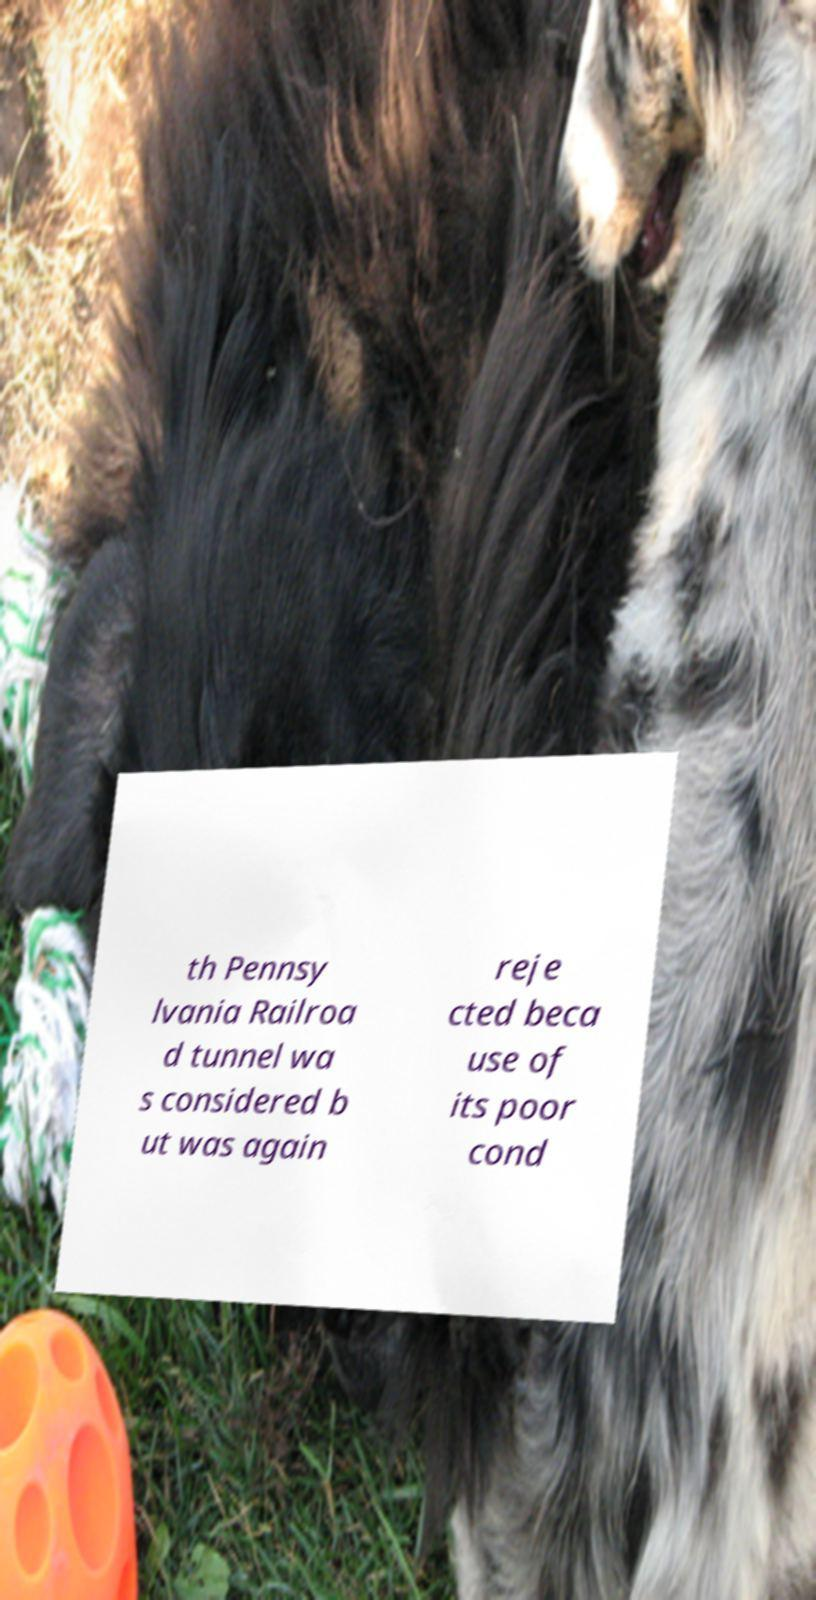Could you assist in decoding the text presented in this image and type it out clearly? th Pennsy lvania Railroa d tunnel wa s considered b ut was again reje cted beca use of its poor cond 